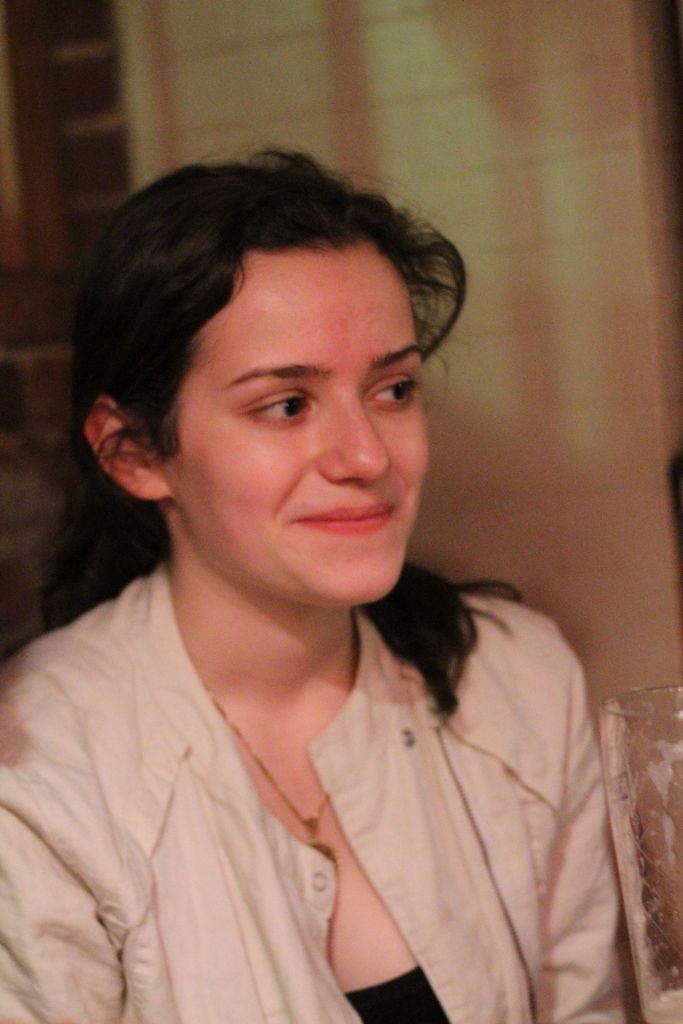Describe this image in one or two sentences. In this picture we can see a woman in a jacket is smiling and behind the woman there is a wall. 